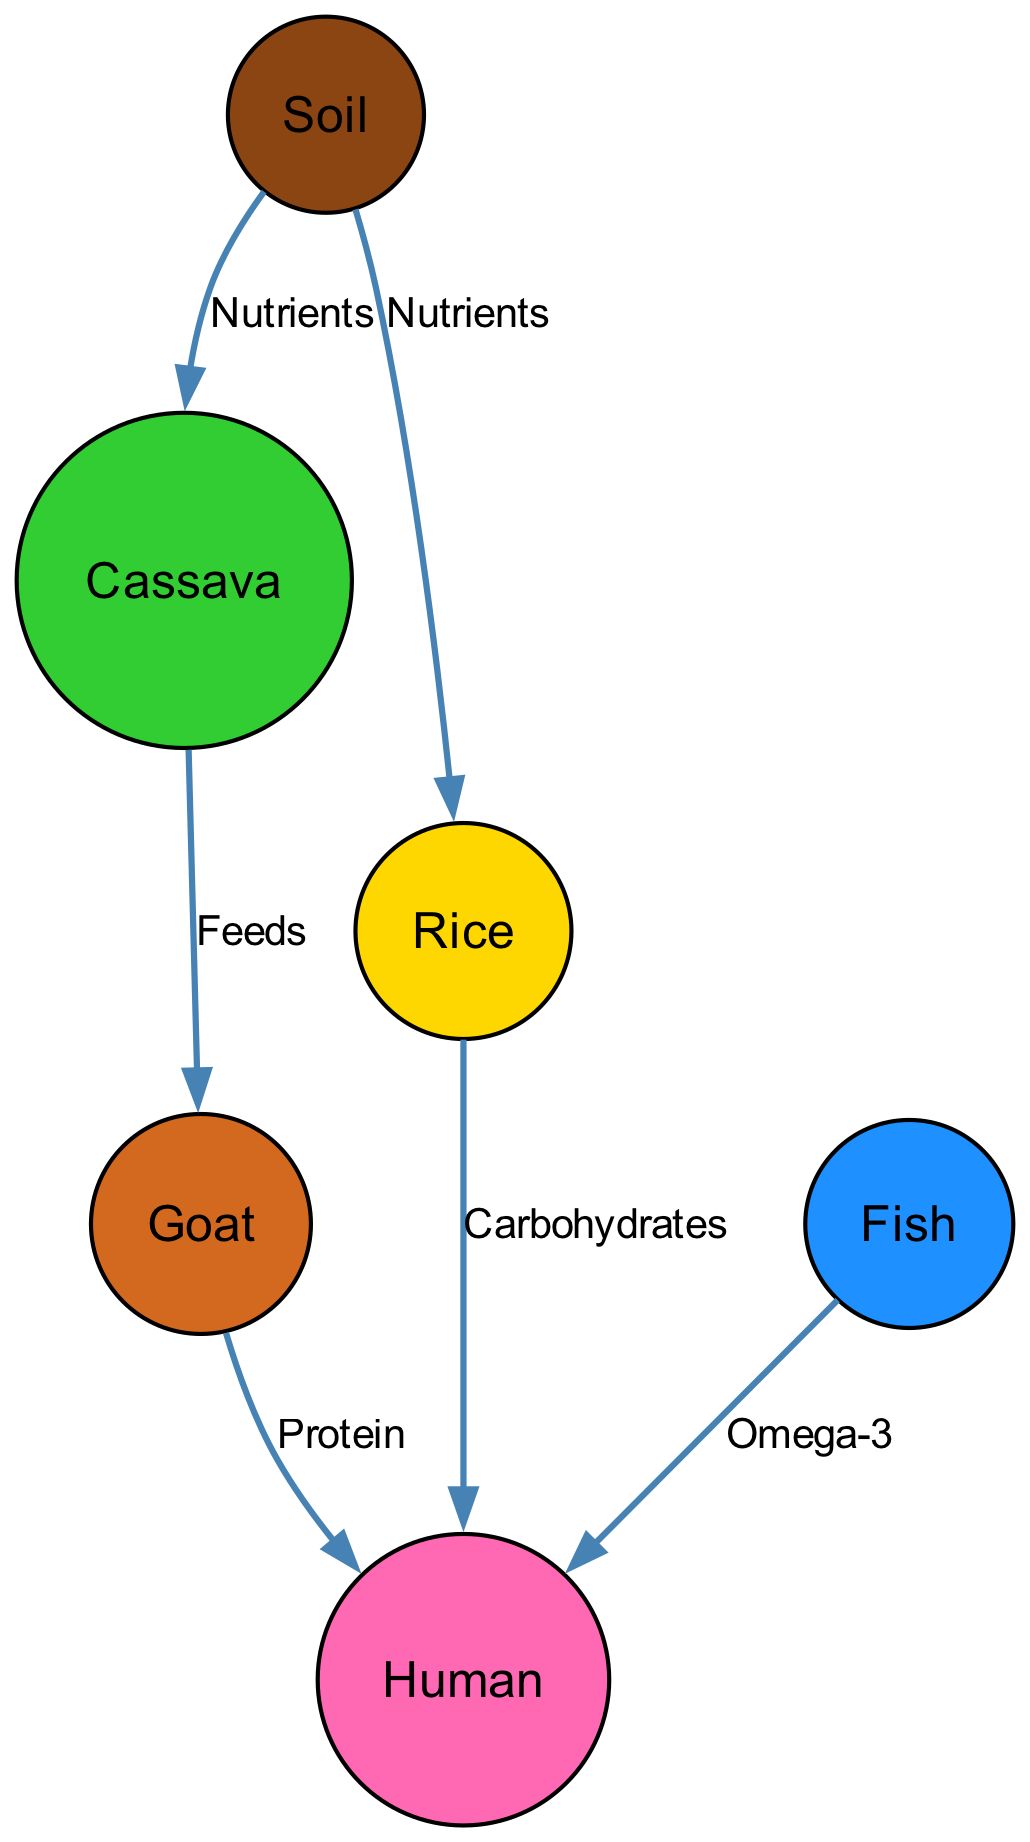What is the starting point of the nutrient flow? The starting point of the nutrient flow is "Soil," as it is the first node and provides nutrients to other elements in the food chain.
Answer: Soil How many nodes are present in the diagram? The diagram contains six nodes: Soil, Cassava, Rice, Goat, Fish, and Human. This can be counted directly from the list of nodes provided.
Answer: 6 Which two plants provide nutrients to humans via carbohydrates? The two plants that provide nutrients to humans via carbohydrates are "Rice" and "Cassava." The diagram indicates that they have a direct connection to humans through the flow of carbohydrates.
Answer: Rice and Cassava What type of nutrients do goats provide to humans? Goats provide "Protein" to humans, as denoted by the labeled edge from Goat to Human in the diagram.
Answer: Protein From which node do both Cassava and Rice receive nutrients? Both Cassava and Rice receive nutrients from the "Soil," which is specified by the two directed edges connecting from Soil to each plant.
Answer: Soil How many different nutrients are shown flowing to humans in the diagram? The diagram shows three different types of nutrients flowing to humans: Carbohydrates from Rice, Protein from Goat, and Omega-3 from Fish. By counting the unique labels on the edges leading to the Human node, we find three distinct nutrients.
Answer: 3 What is the relationship between Cassava and Goat? The relationship between Cassava and Goat is that "Cassava" feeds "Goat," indicating that goats consume cassava as part of their diet, as per the directed edge.
Answer: Feeds Which animal in the diagram directly receives nutrients from the "Soil"? The animal "Goat" directly receives nutrients from the "Soil" as indicated by the directed edge flowing from Soil to Cassava, which in turn feeds the Goat.
Answer: Goat What nutrient does Fish provide to humans? Fish provides "Omega-3" to humans, as shown by the directed edge labeled with Omega-3 flowing from Fish to Human.
Answer: Omega-3 